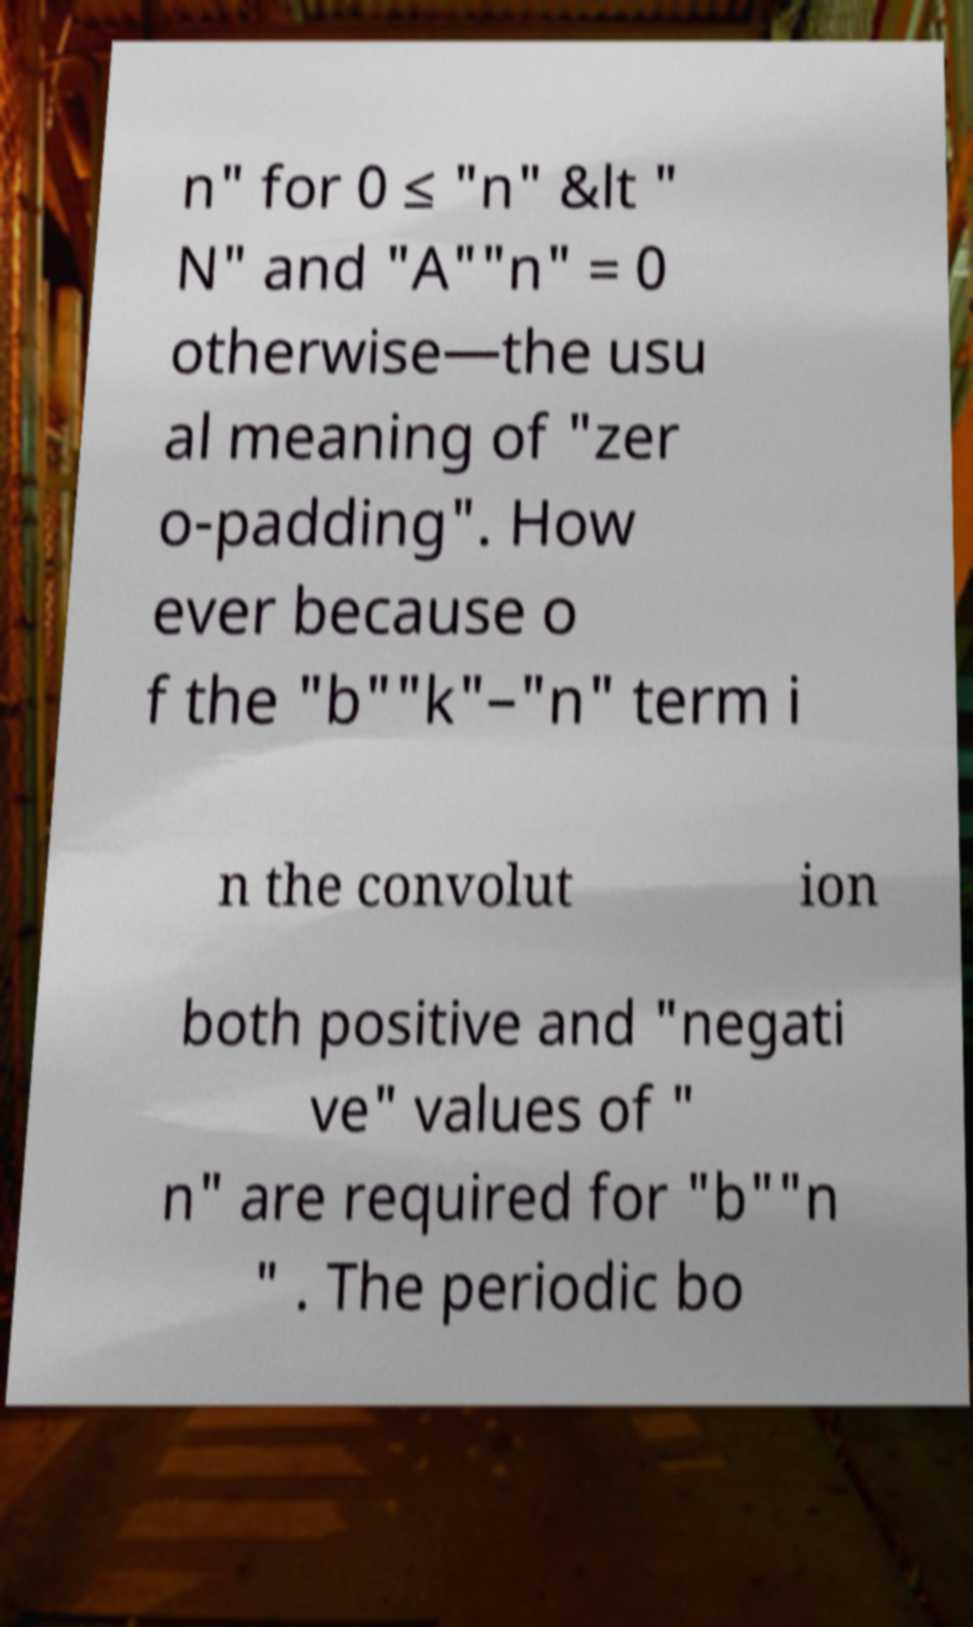Can you accurately transcribe the text from the provided image for me? n" for 0 ≤ "n" &lt " N" and "A""n" = 0 otherwise—the usu al meaning of "zer o-padding". How ever because o f the "b""k"–"n" term i n the convolut ion both positive and "negati ve" values of " n" are required for "b""n " . The periodic bo 